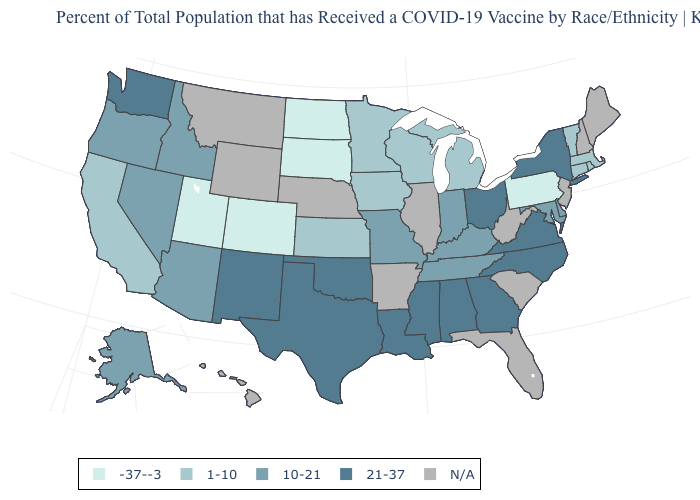What is the lowest value in states that border Connecticut?
Quick response, please. 1-10. What is the value of Oklahoma?
Keep it brief. 21-37. What is the value of Illinois?
Concise answer only. N/A. What is the highest value in the MidWest ?
Give a very brief answer. 21-37. What is the lowest value in states that border Oregon?
Be succinct. 1-10. Which states hav the highest value in the South?
Concise answer only. Alabama, Georgia, Louisiana, Mississippi, North Carolina, Oklahoma, Texas, Virginia. What is the highest value in the MidWest ?
Give a very brief answer. 21-37. Among the states that border Montana , which have the highest value?
Keep it brief. Idaho. Name the states that have a value in the range 10-21?
Be succinct. Alaska, Arizona, Delaware, Idaho, Indiana, Kentucky, Maryland, Missouri, Nevada, Oregon, Tennessee. Which states have the lowest value in the Northeast?
Concise answer only. Pennsylvania. Among the states that border West Virginia , does Ohio have the highest value?
Quick response, please. Yes. Which states have the lowest value in the USA?
Short answer required. Colorado, North Dakota, Pennsylvania, South Dakota, Utah. What is the lowest value in states that border Nebraska?
Write a very short answer. -37--3. Does the map have missing data?
Quick response, please. Yes. 